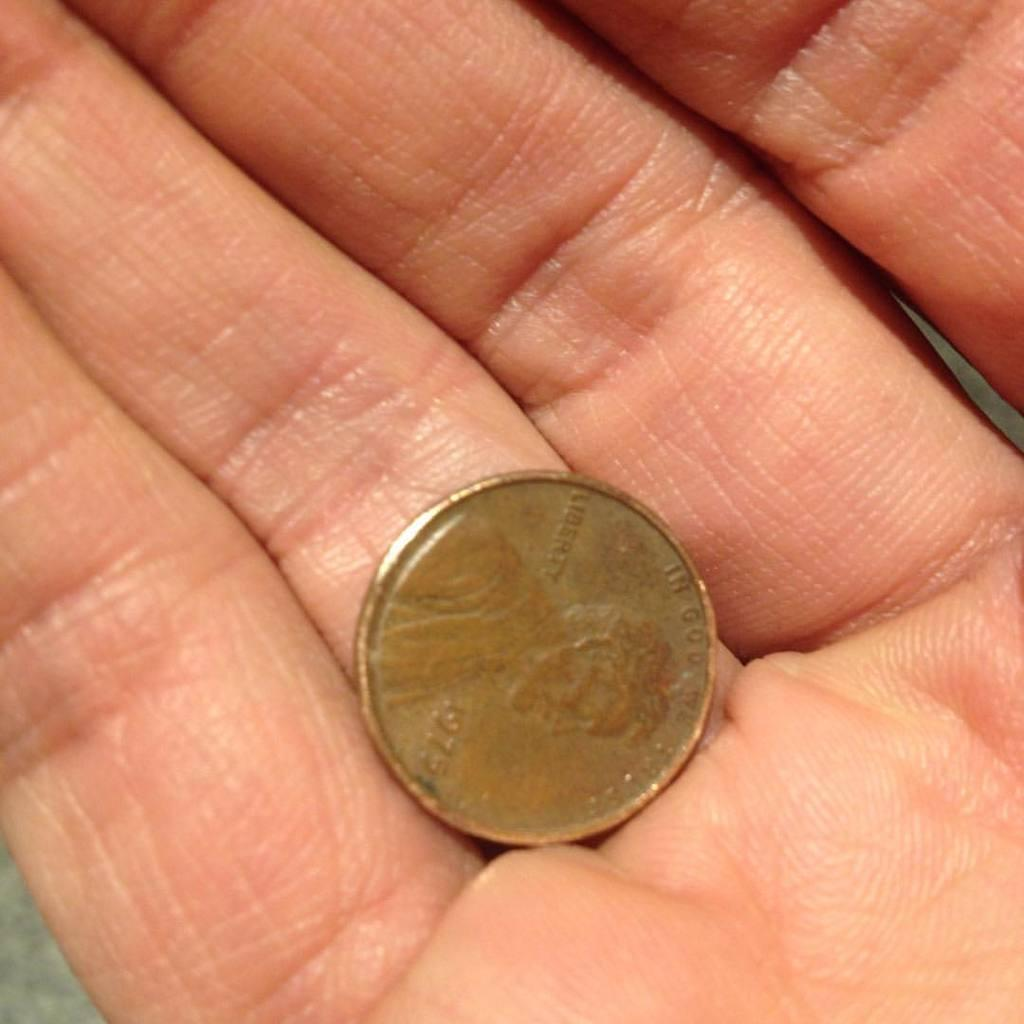<image>
Write a terse but informative summary of the picture. A person holds a 1975 penny in their right hand. 